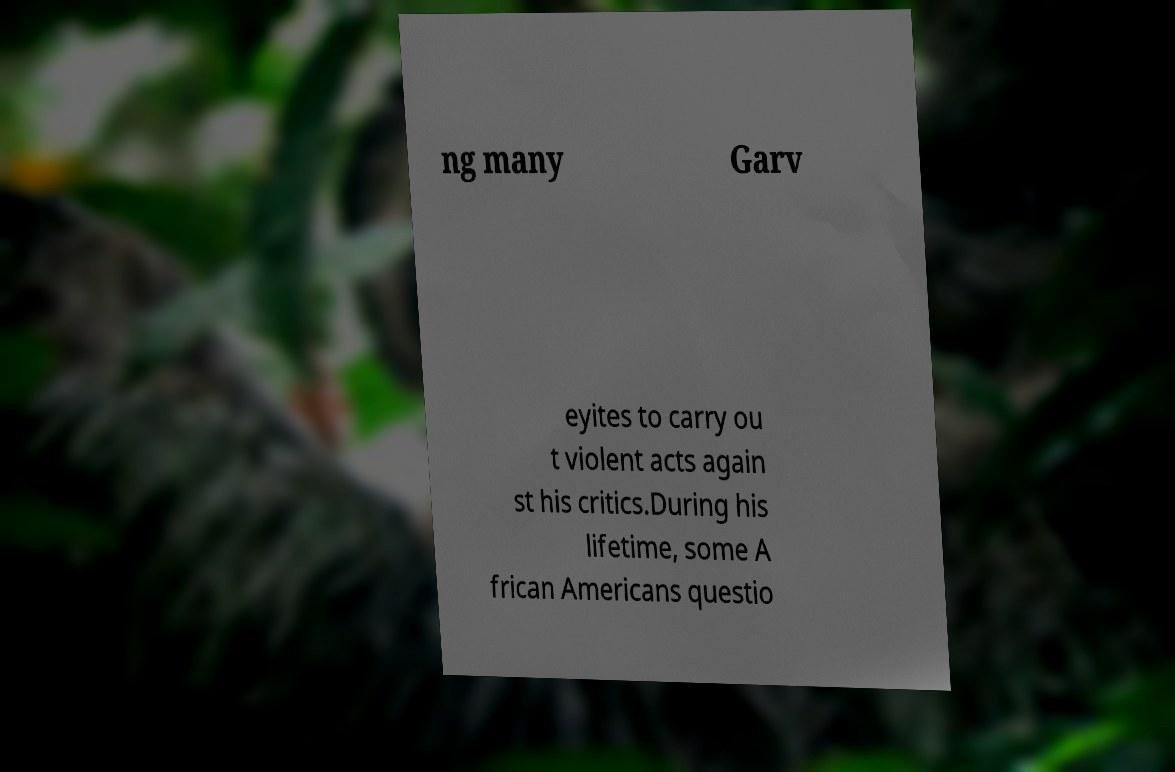What messages or text are displayed in this image? I need them in a readable, typed format. ng many Garv eyites to carry ou t violent acts again st his critics.During his lifetime, some A frican Americans questio 